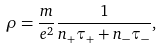Convert formula to latex. <formula><loc_0><loc_0><loc_500><loc_500>\rho = \frac { m } { e ^ { 2 } } \frac { 1 } { n _ { + } \tau _ { + } + n _ { - } \tau _ { - } } ,</formula> 